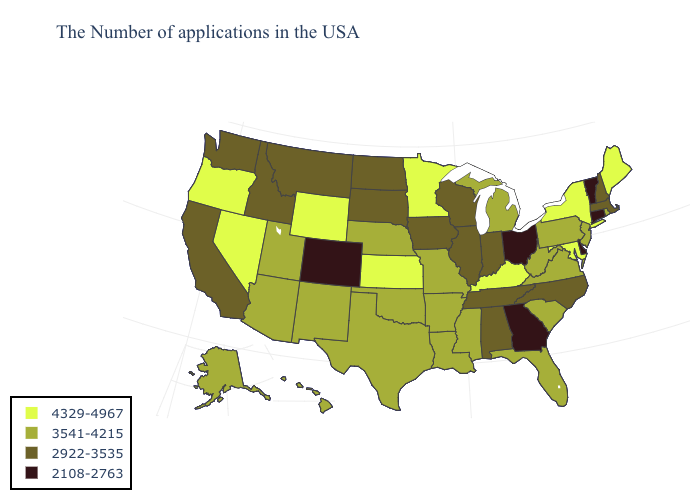Among the states that border New Jersey , which have the highest value?
Answer briefly. New York. What is the value of Idaho?
Give a very brief answer. 2922-3535. Does Illinois have the same value as Maryland?
Write a very short answer. No. Does North Dakota have the same value as Pennsylvania?
Short answer required. No. Among the states that border Idaho , which have the lowest value?
Be succinct. Montana, Washington. Name the states that have a value in the range 3541-4215?
Quick response, please. Rhode Island, New Jersey, Pennsylvania, Virginia, South Carolina, West Virginia, Florida, Michigan, Mississippi, Louisiana, Missouri, Arkansas, Nebraska, Oklahoma, Texas, New Mexico, Utah, Arizona, Alaska, Hawaii. Does Arizona have the lowest value in the USA?
Keep it brief. No. What is the value of Colorado?
Give a very brief answer. 2108-2763. Among the states that border New Mexico , which have the lowest value?
Give a very brief answer. Colorado. Name the states that have a value in the range 2108-2763?
Short answer required. Vermont, Connecticut, Delaware, Ohio, Georgia, Colorado. What is the value of California?
Be succinct. 2922-3535. Among the states that border Florida , does Alabama have the highest value?
Give a very brief answer. Yes. What is the lowest value in states that border Idaho?
Short answer required. 2922-3535. Does the map have missing data?
Quick response, please. No. Among the states that border California , which have the lowest value?
Quick response, please. Arizona. 